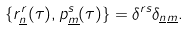Convert formula to latex. <formula><loc_0><loc_0><loc_500><loc_500>\{ r ^ { r } _ { \underline { n } } ( \tau ) , p ^ { s } _ { \underline { m } } ( \tau ) \} = \delta ^ { r s } \delta _ { \underline { n } \underline { m } } .</formula> 